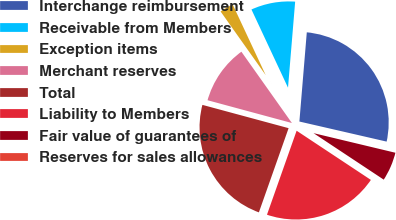Convert chart. <chart><loc_0><loc_0><loc_500><loc_500><pie_chart><fcel>Interchange reimbursement<fcel>Receivable from Members<fcel>Exception items<fcel>Merchant reserves<fcel>Total<fcel>Liability to Members<fcel>Fair value of guarantees of<fcel>Reserves for sales allowances<nl><fcel>27.28%<fcel>8.28%<fcel>2.85%<fcel>10.99%<fcel>23.8%<fcel>21.09%<fcel>5.57%<fcel>0.14%<nl></chart> 